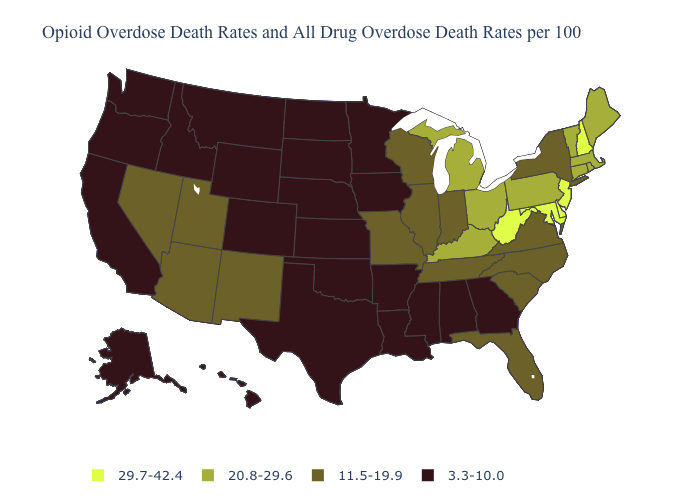Name the states that have a value in the range 29.7-42.4?
Short answer required. Delaware, Maryland, New Hampshire, New Jersey, West Virginia. Name the states that have a value in the range 11.5-19.9?
Quick response, please. Arizona, Florida, Illinois, Indiana, Missouri, Nevada, New Mexico, New York, North Carolina, South Carolina, Tennessee, Utah, Virginia, Wisconsin. Does Pennsylvania have a higher value than West Virginia?
Concise answer only. No. Does Washington have the lowest value in the West?
Quick response, please. Yes. Does Kansas have a higher value than Minnesota?
Short answer required. No. What is the highest value in the USA?
Quick response, please. 29.7-42.4. Which states hav the highest value in the Northeast?
Give a very brief answer. New Hampshire, New Jersey. What is the lowest value in the USA?
Give a very brief answer. 3.3-10.0. Among the states that border Georgia , which have the highest value?
Concise answer only. Florida, North Carolina, South Carolina, Tennessee. Does Rhode Island have the highest value in the USA?
Answer briefly. No. Among the states that border Arizona , which have the highest value?
Give a very brief answer. Nevada, New Mexico, Utah. Does Nevada have a higher value than Wisconsin?
Write a very short answer. No. Among the states that border New Jersey , does Delaware have the highest value?
Answer briefly. Yes. What is the highest value in the USA?
Give a very brief answer. 29.7-42.4. Name the states that have a value in the range 29.7-42.4?
Concise answer only. Delaware, Maryland, New Hampshire, New Jersey, West Virginia. 